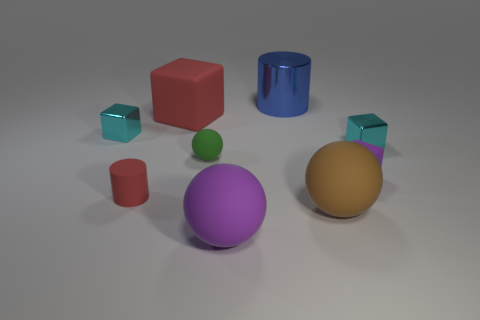Is the metallic cylinder the same size as the green matte object?
Make the answer very short. No. Are there any cyan blocks of the same size as the purple matte cube?
Ensure brevity in your answer.  Yes. What material is the cyan cube that is to the left of the big purple ball?
Make the answer very short. Metal. The tiny sphere that is the same material as the large red block is what color?
Ensure brevity in your answer.  Green. How many metallic things are either big gray blocks or purple balls?
Your response must be concise. 0. There is a red rubber thing that is the same size as the purple sphere; what is its shape?
Provide a succinct answer. Cube. What number of objects are blue metallic things behind the big red cube or cyan metallic cubes that are on the left side of the big red block?
Offer a terse response. 2. What material is the purple object that is the same size as the green sphere?
Make the answer very short. Rubber. What number of other objects are there of the same material as the small red thing?
Provide a short and direct response. 5. Are there the same number of red objects that are left of the red cylinder and red rubber cylinders to the right of the big purple matte sphere?
Your response must be concise. Yes. 